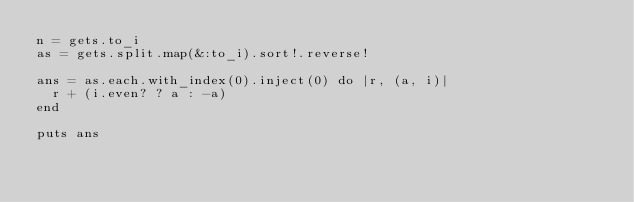<code> <loc_0><loc_0><loc_500><loc_500><_Ruby_>n = gets.to_i
as = gets.split.map(&:to_i).sort!.reverse!

ans = as.each.with_index(0).inject(0) do |r, (a, i)|
  r + (i.even? ? a : -a)
end

puts ans
</code> 